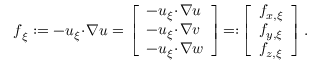<formula> <loc_0><loc_0><loc_500><loc_500>\begin{array} { r } { f _ { \xi } \colon = - u _ { \xi } \, \cdot \, \nabla u = \left [ \begin{array} { l } { - u _ { \xi } \, \cdot \, \nabla u } \\ { - u _ { \xi } \, \cdot \, \nabla v } \\ { - u _ { \xi } \, \cdot \, \nabla w } \end{array} \right ] \, = \colon \, \left [ \begin{array} { l } { f _ { x , \xi } } \\ { f _ { y , \xi } } \\ { f _ { z , \xi } } \end{array} \right ] . } \end{array}</formula> 